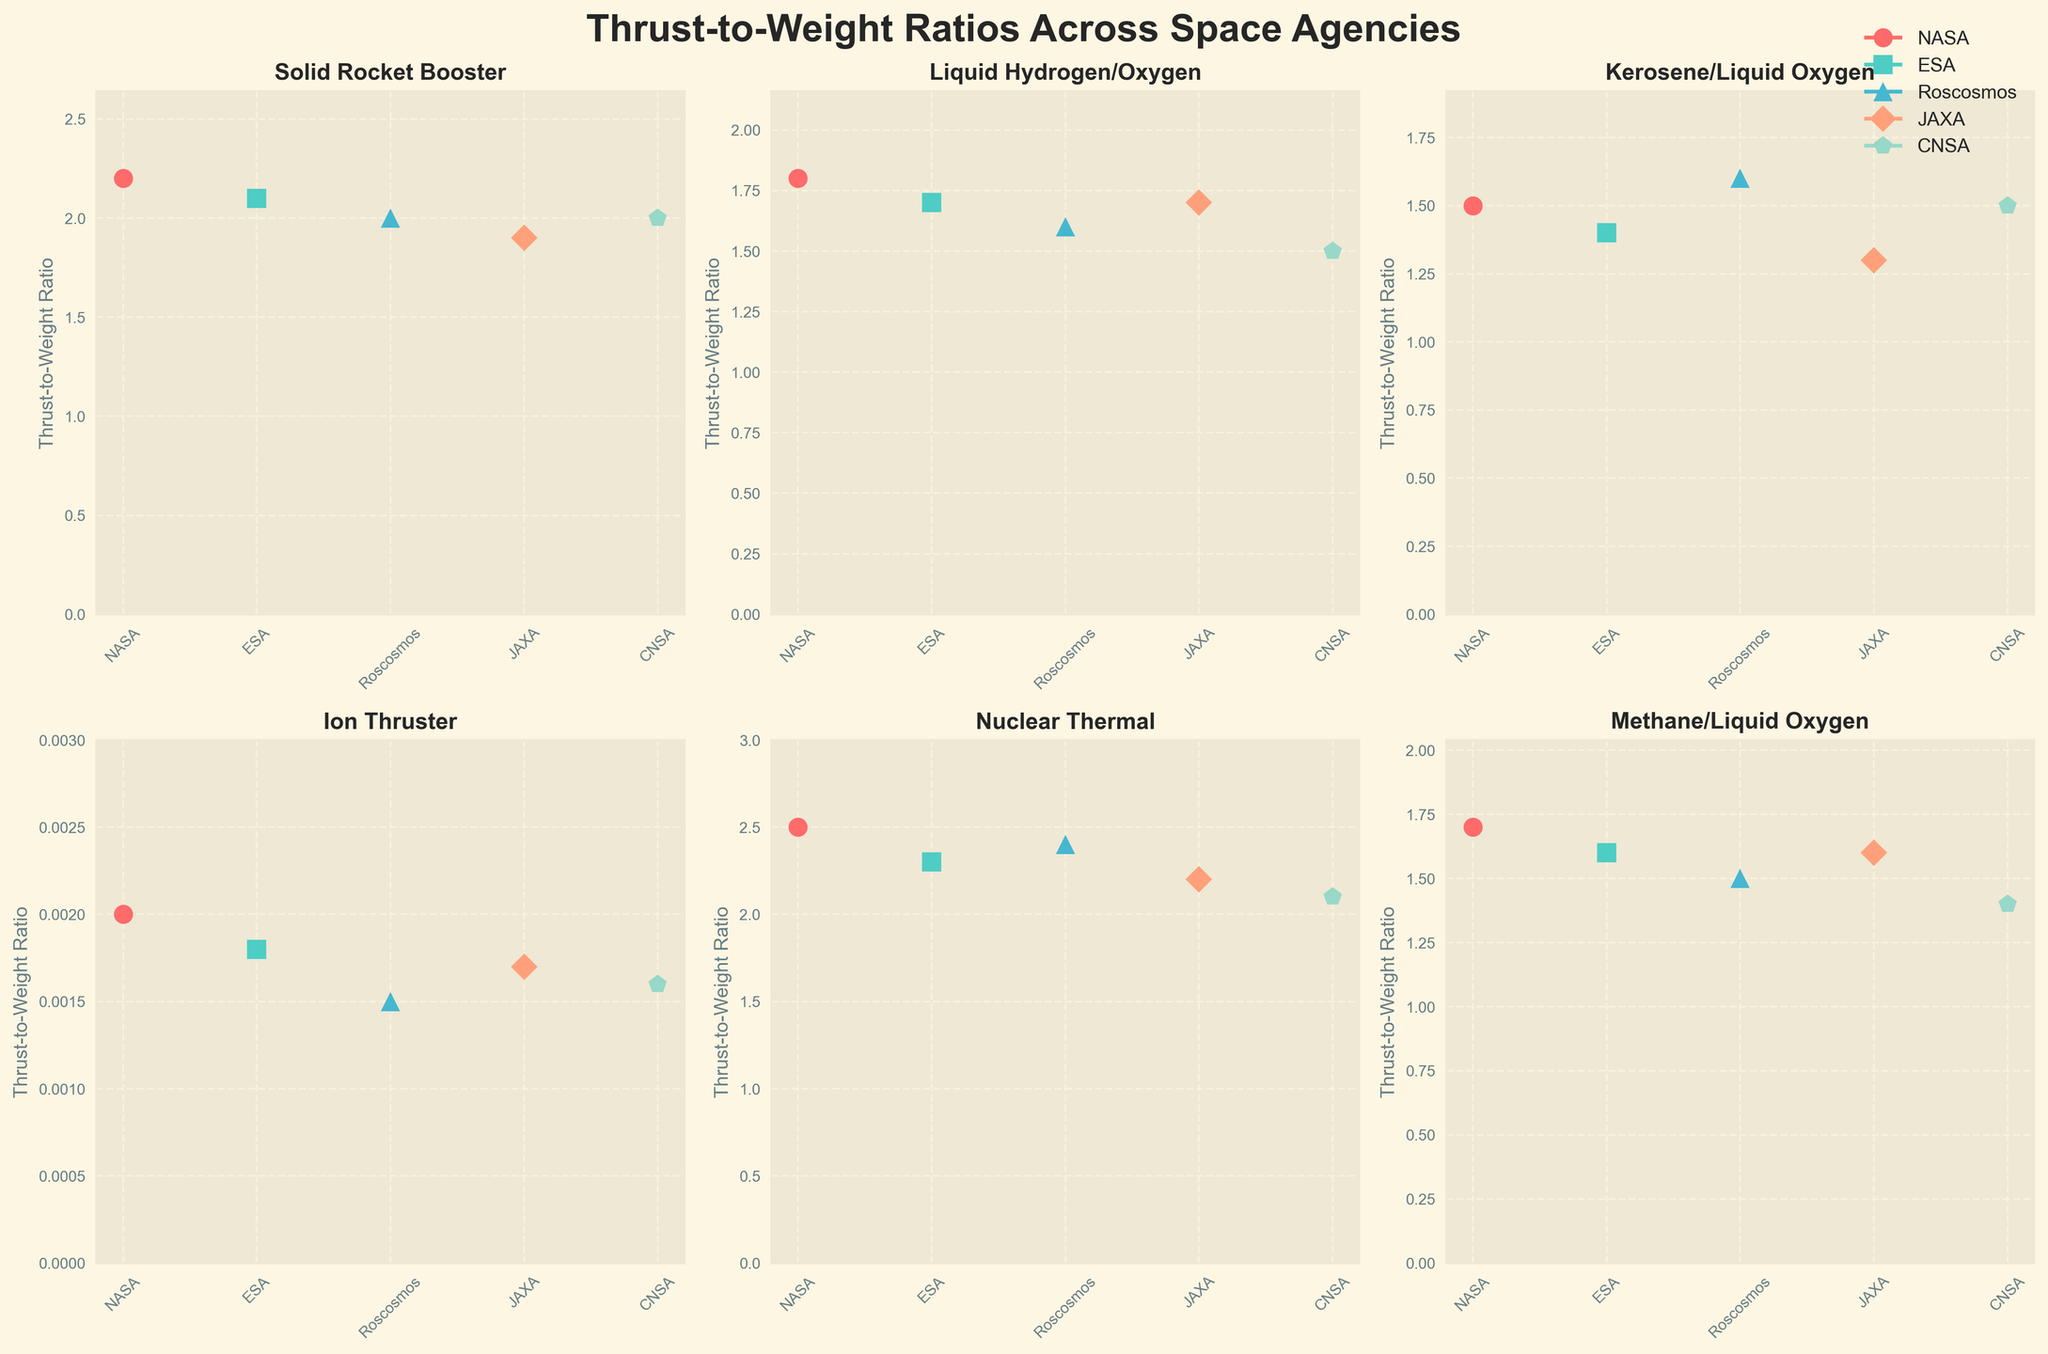What is the title of the figure? The title of the figure is typically found at the top center, summarizing the content of the figure.
Answer: Thrust-to-Weight Ratios Across Space Agencies Which propulsion system has the highest thrust-to-weight ratio across all space agencies? To find the highest thrust-to-weight ratio, observe each subplot and compare the values. The maximum value across all subplots is for Nuclear Thermal.
Answer: Nuclear Thermal Which space agency exhibits the lowest thrust-to-weight ratio for the Ion Thruster propulsion system? Look at the subplot for Ion Thruster and compare the thrust-to-weight ratios for all space agencies. The lowest value is for Roscosmos.
Answer: Roscosmos What is the difference between the maximum and minimum thrust-to-weight ratios for the Kerosene/Liquid Oxygen propulsion system? Identify the values for the Kerosene/Liquid Oxygen propulsion system on its subplot and calculate the difference between the maximum (1.6 from Roscosmos) and minimum (1.3 from JAXA) values.
Answer: 0.3 Does NASA consistently have the highest thrust-to-weight ratios across all propulsion systems? Check each subplot to see if NASA's value is the highest among all space agencies for each propulsion system. NASA does not consistently have the highest values; for example, the highest for Ion Thrusters is not from NASA.
Answer: No Which propulsion system shows the largest variation in thrust-to-weight ratios across different space agencies? For each propulsion system, calculate the difference between its maximum and minimum thrust-to-weight ratios across space agencies and identify the system with the largest difference. Nuclear Thermal shows the largest variation (2.5 - 2.1 = 0.4).
Answer: Nuclear Thermal What is the average thrust-to-weight ratio for the Liquid Hydrogen/Oxygen propulsion system across all space agencies? Sum the thrust-to-weight ratios for the Liquid Hydrogen/Oxygen propulsion system (1.8+1.7+1.6+1.7+1.5=8.3) and divide by the number of space agencies (5).
Answer: 1.66 Which space agency has the closest thrust-to-weight ratio values for Solid Rocket Booster and Methane/Liquid Oxygen propulsion systems? Compare the values for Solid Rocket Booster and Methane/Liquid Oxygen for each space agency to find the smallest absolute difference. For ESA, the ratios are 2.1 (Solid Rocket Booster) and 1.6 (Methane/LOX), with a difference of 0.5, which is the smallest difference.
Answer: ESA Among the plotted propulsion systems, how many show a thrust-to-weight ratio higher than 2.0 for at least one space agency? Count the number of propulsion systems where the maximum thrust-to-weight ratio is greater than 2.0. Solid Rocket Booster and Nuclear Thermal meet this criterion, totaling 2.
Answer: 2 